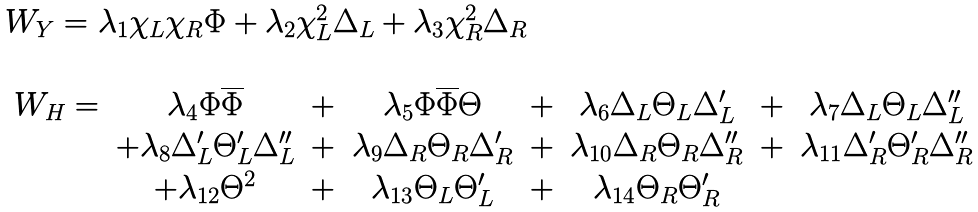<formula> <loc_0><loc_0><loc_500><loc_500>\begin{array} { l } W _ { Y } = { \lambda _ { 1 } } \chi _ { L } \chi _ { R } \Phi + { \lambda _ { 2 } } \chi _ { L } ^ { 2 } \Delta _ { L } + { \lambda _ { 3 } } \chi _ { R } ^ { 2 } \Delta _ { R } \\ \\ \begin{array} { c c c c c c c c } W _ { H } = & \lambda _ { 4 } \Phi \overline { \Phi } & + & \lambda _ { 5 } \Phi \overline { \Phi } \Theta & + & \lambda _ { 6 } \Delta _ { L } \Theta _ { L } \Delta ^ { \prime } _ { L } & + & \lambda _ { 7 } \Delta _ { L } \Theta _ { L } \Delta ^ { \prime \prime } _ { L } \\ & + \lambda _ { 8 } \Delta ^ { \prime } _ { L } \Theta ^ { \prime } _ { L } \Delta ^ { \prime \prime } _ { L } & + & \lambda _ { 9 } \Delta _ { R } \Theta _ { R } \Delta ^ { \prime } _ { R } & + & \lambda _ { 1 0 } \Delta _ { R } \Theta _ { R } \Delta ^ { \prime \prime } _ { R } & + & \lambda _ { 1 1 } \Delta ^ { \prime } _ { R } \Theta ^ { \prime } _ { R } \Delta ^ { \prime \prime } _ { R } \\ & + \lambda _ { 1 2 } \Theta ^ { 2 } & + & \lambda _ { 1 3 } \Theta _ { L } \Theta ^ { \prime } _ { L } & + & \lambda _ { 1 4 } \Theta _ { R } \Theta ^ { \prime } _ { R } \\ \end{array} \\ \end{array}</formula> 